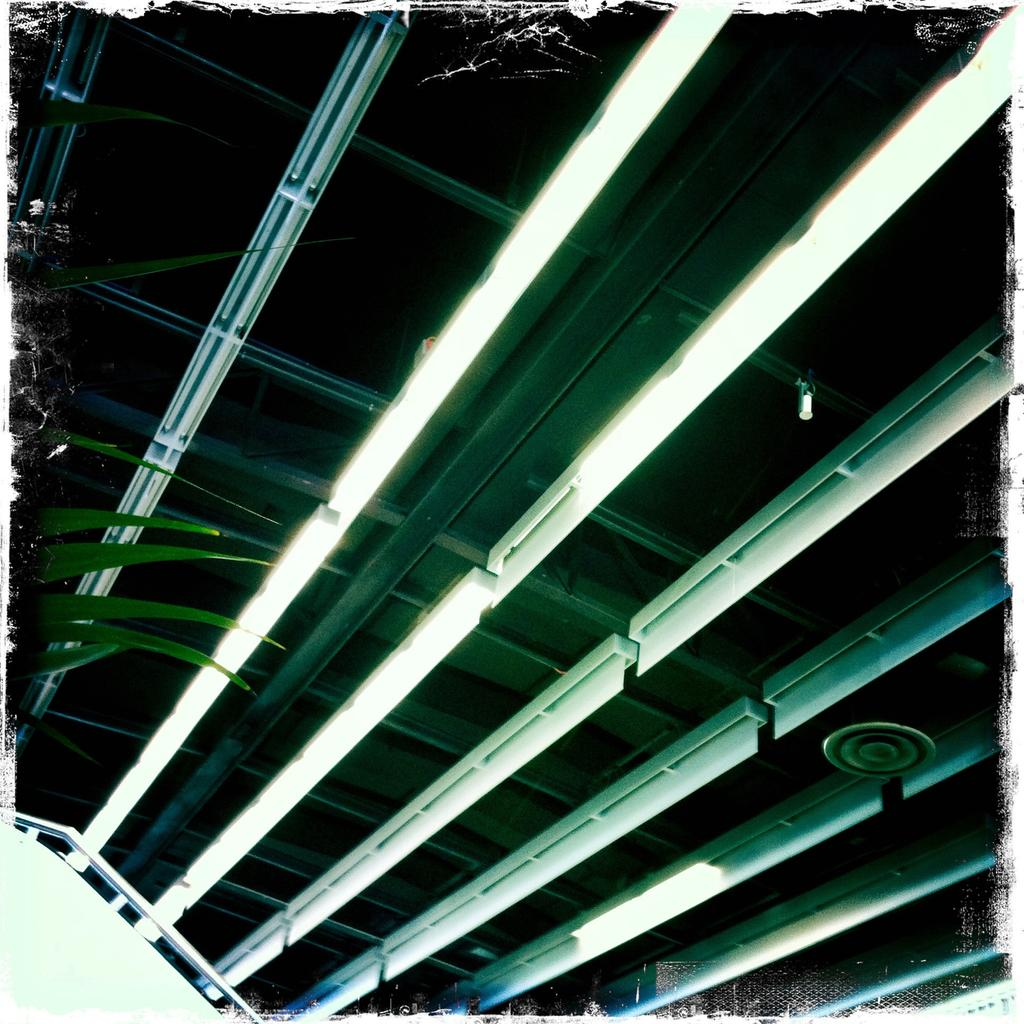What structure is visible in the image? There is a roof in the image. What can be seen on the roof? There are lights on the roof. What type of vegetation is on the left side of the image? There is a plant on the left side of the image. Can you tell me how many sailboats are on the river in the image? There is no river or sailboats present in the image; it features a roof with lights and a plant. What type of pleasure activity is happening in the image? There is no pleasure activity depicted in the image; it only shows a roof, lights, and a plant. 